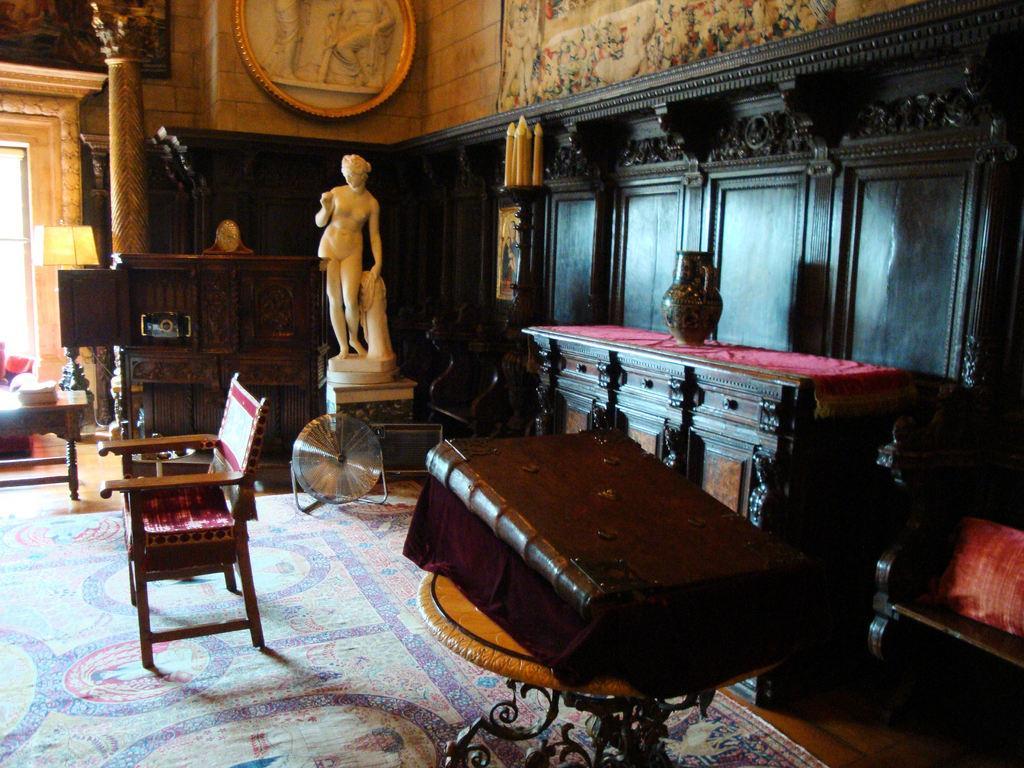Please provide a concise description of this image. In this image I can see a chair, a brown colored surface and on it I can see a huge book which is brown in color, a statue which is cream in color and the black colored furniture. In the background I can see the brown colored wall, a photo frame attached to the wall and few other objects. 